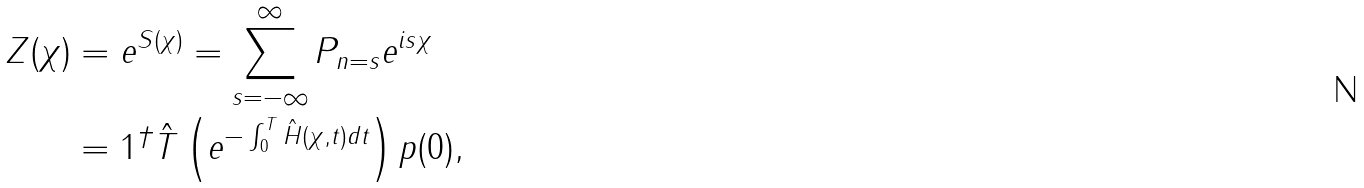<formula> <loc_0><loc_0><loc_500><loc_500>Z ( \chi ) & = e ^ { S ( \chi ) } = \sum _ { s = - \infty } ^ { \infty } P _ { n = s } e ^ { i s \chi } \\ & = 1 ^ { \dagger } \hat { T } \left ( e ^ { - \int _ { 0 } ^ { T } \hat { H } ( \chi , t ) d t } \right ) p ( 0 ) ,</formula> 